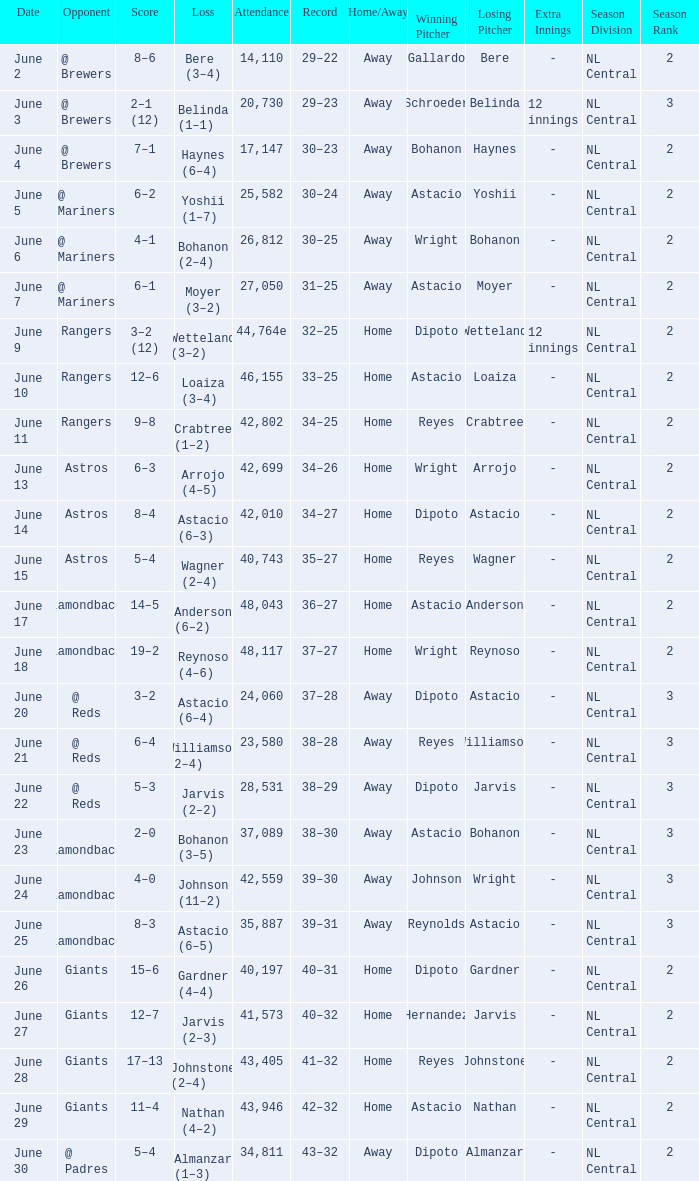Who's the opponent for June 13? Astros. 